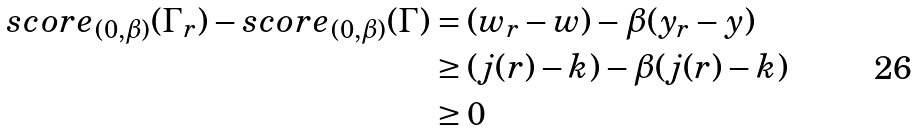Convert formula to latex. <formula><loc_0><loc_0><loc_500><loc_500>s c o r e _ { ( 0 , \beta ) } ( \Gamma _ { r } ) - s c o r e _ { ( 0 , \beta ) } ( \Gamma ) & = ( w _ { r } - w ) - \beta ( y _ { r } - y ) \\ & \geq ( j ( r ) - k ) - \beta ( j ( r ) - k ) \\ & \geq 0</formula> 